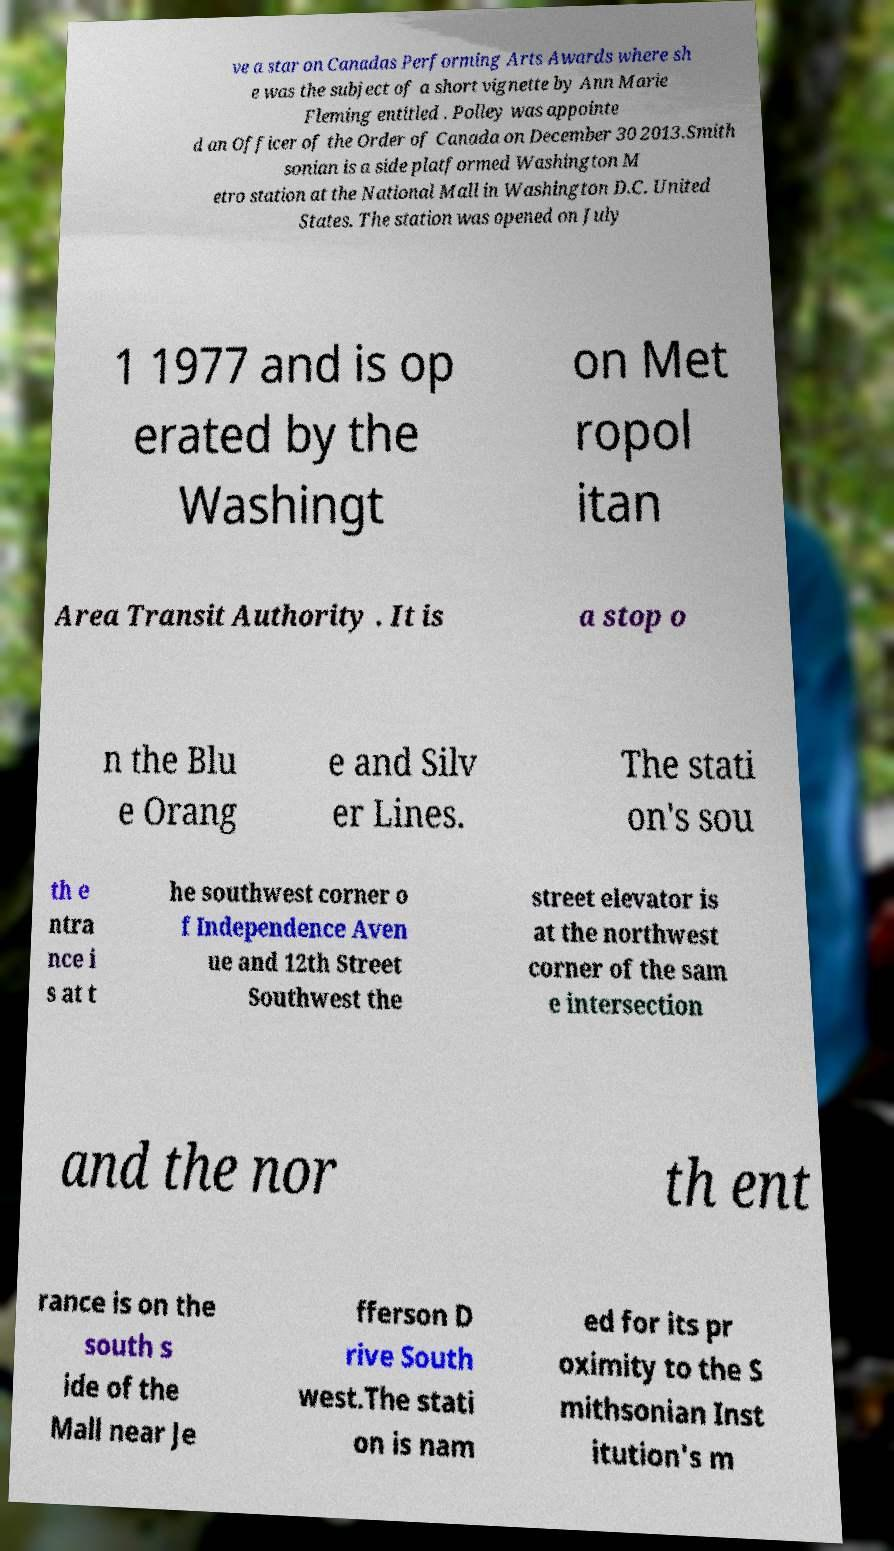What messages or text are displayed in this image? I need them in a readable, typed format. ve a star on Canadas Performing Arts Awards where sh e was the subject of a short vignette by Ann Marie Fleming entitled . Polley was appointe d an Officer of the Order of Canada on December 30 2013.Smith sonian is a side platformed Washington M etro station at the National Mall in Washington D.C. United States. The station was opened on July 1 1977 and is op erated by the Washingt on Met ropol itan Area Transit Authority . It is a stop o n the Blu e Orang e and Silv er Lines. The stati on's sou th e ntra nce i s at t he southwest corner o f Independence Aven ue and 12th Street Southwest the street elevator is at the northwest corner of the sam e intersection and the nor th ent rance is on the south s ide of the Mall near Je fferson D rive South west.The stati on is nam ed for its pr oximity to the S mithsonian Inst itution's m 